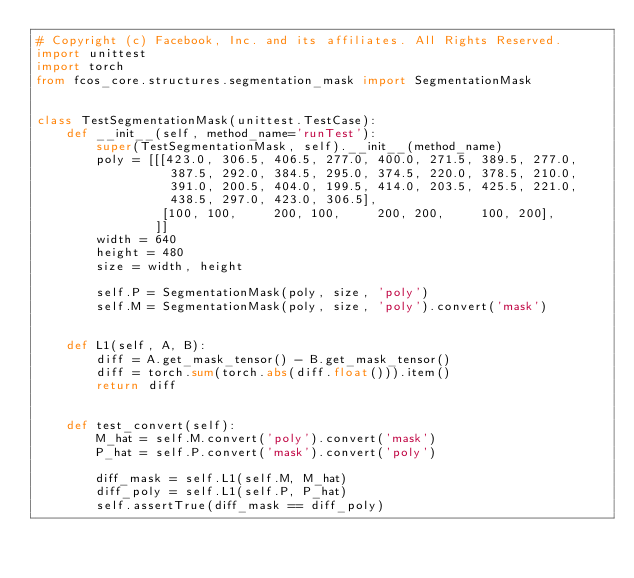<code> <loc_0><loc_0><loc_500><loc_500><_Python_># Copyright (c) Facebook, Inc. and its affiliates. All Rights Reserved.
import unittest
import torch
from fcos_core.structures.segmentation_mask import SegmentationMask


class TestSegmentationMask(unittest.TestCase):
    def __init__(self, method_name='runTest'):
        super(TestSegmentationMask, self).__init__(method_name)
        poly = [[[423.0, 306.5, 406.5, 277.0, 400.0, 271.5, 389.5, 277.0,
                  387.5, 292.0, 384.5, 295.0, 374.5, 220.0, 378.5, 210.0,
                  391.0, 200.5, 404.0, 199.5, 414.0, 203.5, 425.5, 221.0,
                  438.5, 297.0, 423.0, 306.5],
                 [100, 100,     200, 100,     200, 200,     100, 200],
                ]]
        width = 640
        height = 480
        size = width, height

        self.P = SegmentationMask(poly, size, 'poly')
        self.M = SegmentationMask(poly, size, 'poly').convert('mask')


    def L1(self, A, B):
        diff = A.get_mask_tensor() - B.get_mask_tensor()
        diff = torch.sum(torch.abs(diff.float())).item()
        return diff


    def test_convert(self):
        M_hat = self.M.convert('poly').convert('mask')
        P_hat = self.P.convert('mask').convert('poly')

        diff_mask = self.L1(self.M, M_hat)
        diff_poly = self.L1(self.P, P_hat)
        self.assertTrue(diff_mask == diff_poly)</code> 